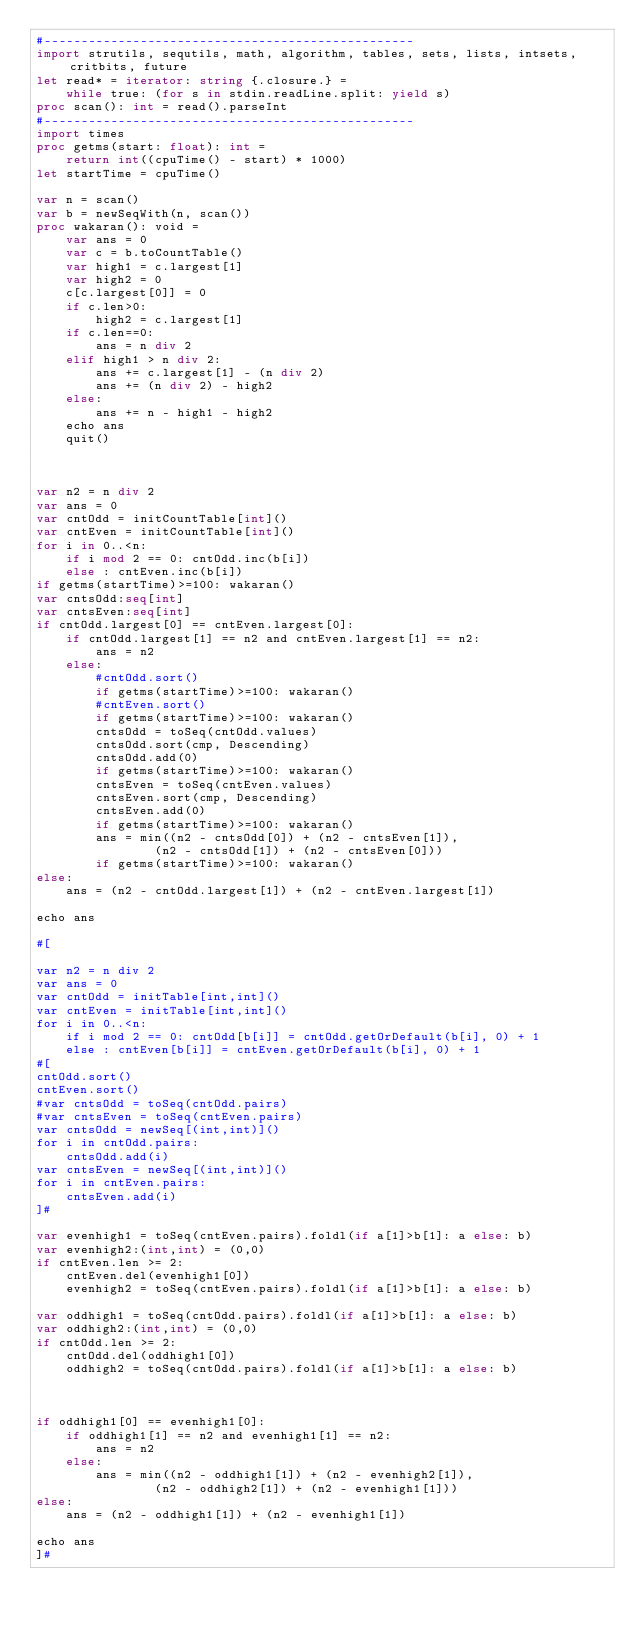Convert code to text. <code><loc_0><loc_0><loc_500><loc_500><_Nim_>#--------------------------------------------------
import strutils, sequtils, math, algorithm, tables, sets, lists, intsets, critbits, future
let read* = iterator: string {.closure.} =
    while true: (for s in stdin.readLine.split: yield s)
proc scan(): int = read().parseInt
#--------------------------------------------------
import times
proc getms(start: float): int =
    return int((cpuTime() - start) * 1000)
let startTime = cpuTime()

var n = scan()
var b = newSeqWith(n, scan())
proc wakaran(): void =
    var ans = 0
    var c = b.toCountTable()
    var high1 = c.largest[1]
    var high2 = 0
    c[c.largest[0]] = 0
    if c.len>0:
        high2 = c.largest[1]
    if c.len==0:
        ans = n div 2
    elif high1 > n div 2:
        ans += c.largest[1] - (n div 2)
        ans += (n div 2) - high2
    else:
        ans += n - high1 - high2
    echo ans
    quit()



var n2 = n div 2
var ans = 0
var cntOdd = initCountTable[int]()
var cntEven = initCountTable[int]()
for i in 0..<n:
    if i mod 2 == 0: cntOdd.inc(b[i])
    else : cntEven.inc(b[i])
if getms(startTime)>=100: wakaran()
var cntsOdd:seq[int]
var cntsEven:seq[int]
if cntOdd.largest[0] == cntEven.largest[0]:
    if cntOdd.largest[1] == n2 and cntEven.largest[1] == n2:
        ans = n2
    else:
        #cntOdd.sort()
        if getms(startTime)>=100: wakaran()
        #cntEven.sort()
        if getms(startTime)>=100: wakaran()
        cntsOdd = toSeq(cntOdd.values)
        cntsOdd.sort(cmp, Descending)
        cntsOdd.add(0)
        if getms(startTime)>=100: wakaran()
        cntsEven = toSeq(cntEven.values)
        cntsEven.sort(cmp, Descending)
        cntsEven.add(0)
        if getms(startTime)>=100: wakaran()
        ans = min((n2 - cntsOdd[0]) + (n2 - cntsEven[1]),
                (n2 - cntsOdd[1]) + (n2 - cntsEven[0]))
        if getms(startTime)>=100: wakaran()
else:
    ans = (n2 - cntOdd.largest[1]) + (n2 - cntEven.largest[1])
 
echo ans

#[

var n2 = n div 2
var ans = 0
var cntOdd = initTable[int,int]()
var cntEven = initTable[int,int]()
for i in 0..<n:
    if i mod 2 == 0: cntOdd[b[i]] = cntOdd.getOrDefault(b[i], 0) + 1
    else : cntEven[b[i]] = cntEven.getOrDefault(b[i], 0) + 1
#[
cntOdd.sort()
cntEven.sort()
#var cntsOdd = toSeq(cntOdd.pairs)
#var cntsEven = toSeq(cntEven.pairs)
var cntsOdd = newSeq[(int,int)]()
for i in cntOdd.pairs:
    cntsOdd.add(i)
var cntsEven = newSeq[(int,int)]()
for i in cntEven.pairs:
    cntsEven.add(i)
]#

var evenhigh1 = toSeq(cntEven.pairs).foldl(if a[1]>b[1]: a else: b)
var evenhigh2:(int,int) = (0,0)
if cntEven.len >= 2:
    cntEven.del(evenhigh1[0])
    evenhigh2 = toSeq(cntEven.pairs).foldl(if a[1]>b[1]: a else: b)

var oddhigh1 = toSeq(cntOdd.pairs).foldl(if a[1]>b[1]: a else: b)
var oddhigh2:(int,int) = (0,0)
if cntOdd.len >= 2:
    cntOdd.del(oddhigh1[0])
    oddhigh2 = toSeq(cntOdd.pairs).foldl(if a[1]>b[1]: a else: b)



if oddhigh1[0] == evenhigh1[0]:
    if oddhigh1[1] == n2 and evenhigh1[1] == n2:
        ans = n2
    else:
        ans = min((n2 - oddhigh1[1]) + (n2 - evenhigh2[1]),
                (n2 - oddhigh2[1]) + (n2 - evenhigh1[1]))
else:
    ans = (n2 - oddhigh1[1]) + (n2 - evenhigh1[1])
 
echo ans
]#</code> 